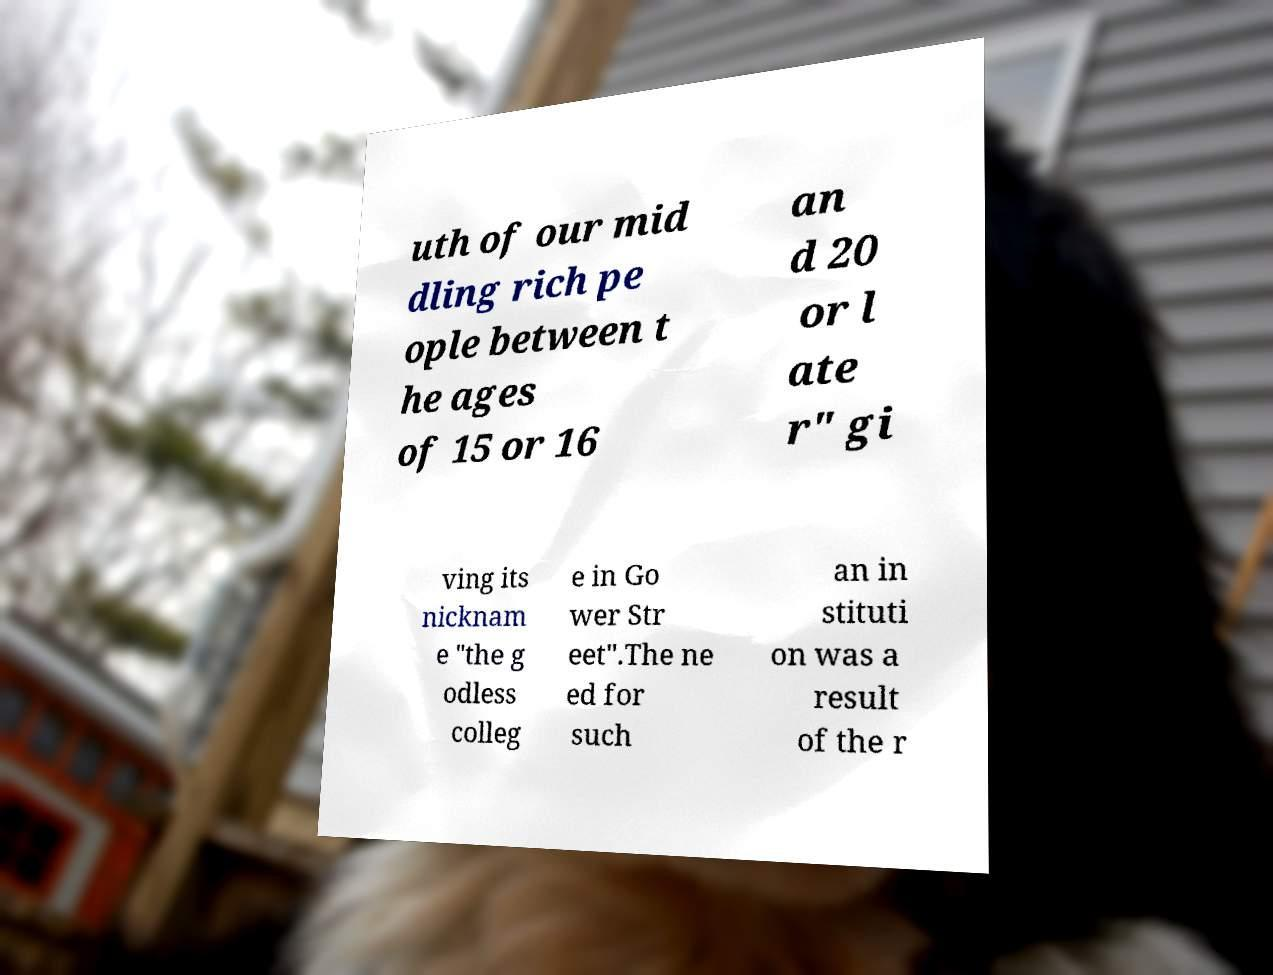I need the written content from this picture converted into text. Can you do that? uth of our mid dling rich pe ople between t he ages of 15 or 16 an d 20 or l ate r" gi ving its nicknam e "the g odless colleg e in Go wer Str eet".The ne ed for such an in stituti on was a result of the r 